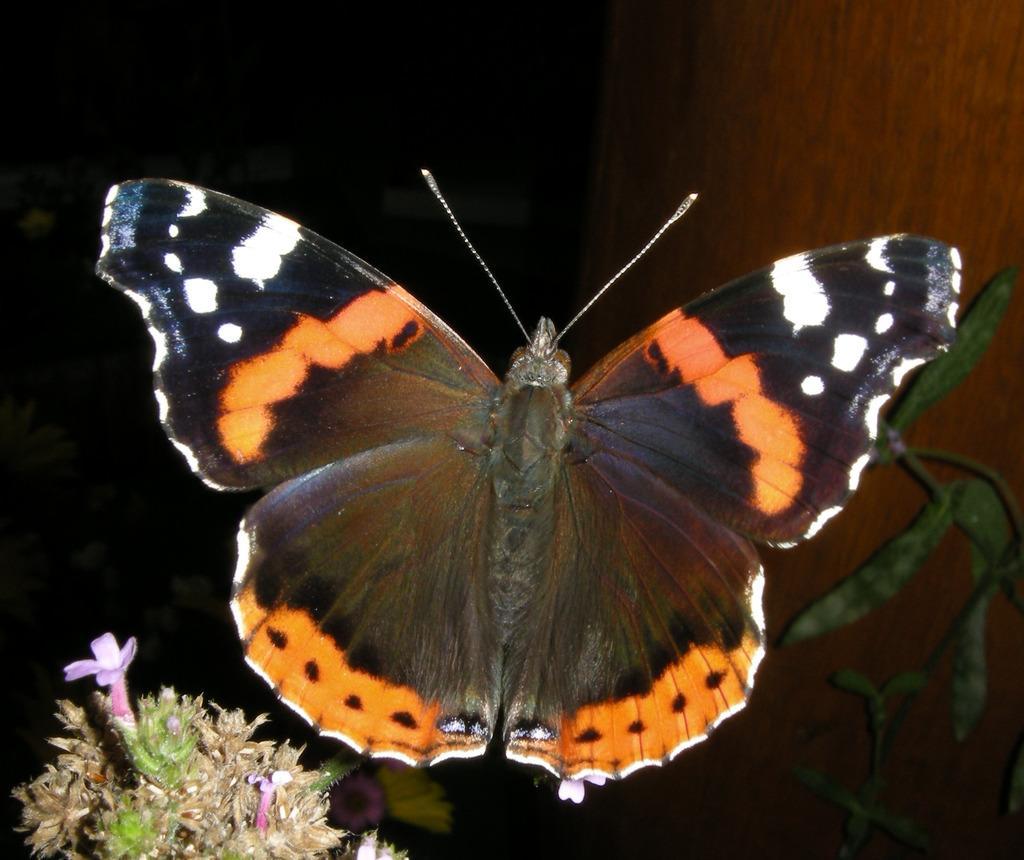Can you describe this image briefly? In this image there is a butterfly on the plant having leaves. Left bottom there is a plant having flowers. Right side there is a wooden trunk. 